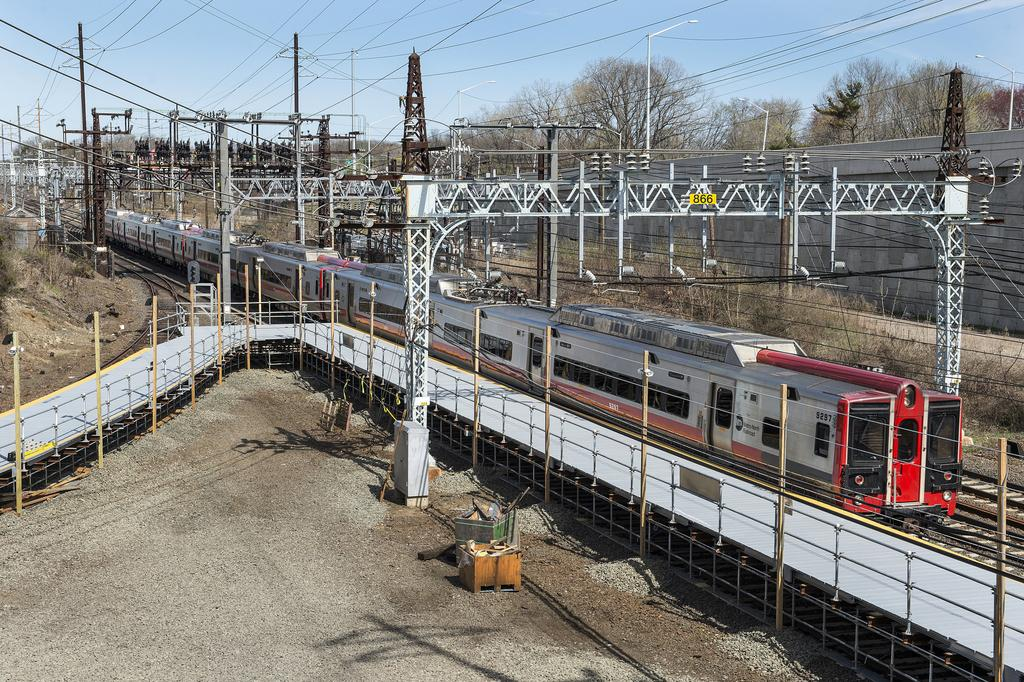What is the main subject of the image? The main subject of the image is a train. Where is the train located? The train is on a railway track. What can be seen behind the train? There are electric poles with cables behind the train. What is on the right side of the train? There is a wall and trees on the right side of the train. What is visible in the background of the image? The sky is visible in the image. How much salt is on the train in the image? There is no salt present on the train in the image. Can you describe the train's ability to roll in the image? The train is stationary in the image and does not appear to be rolling. 